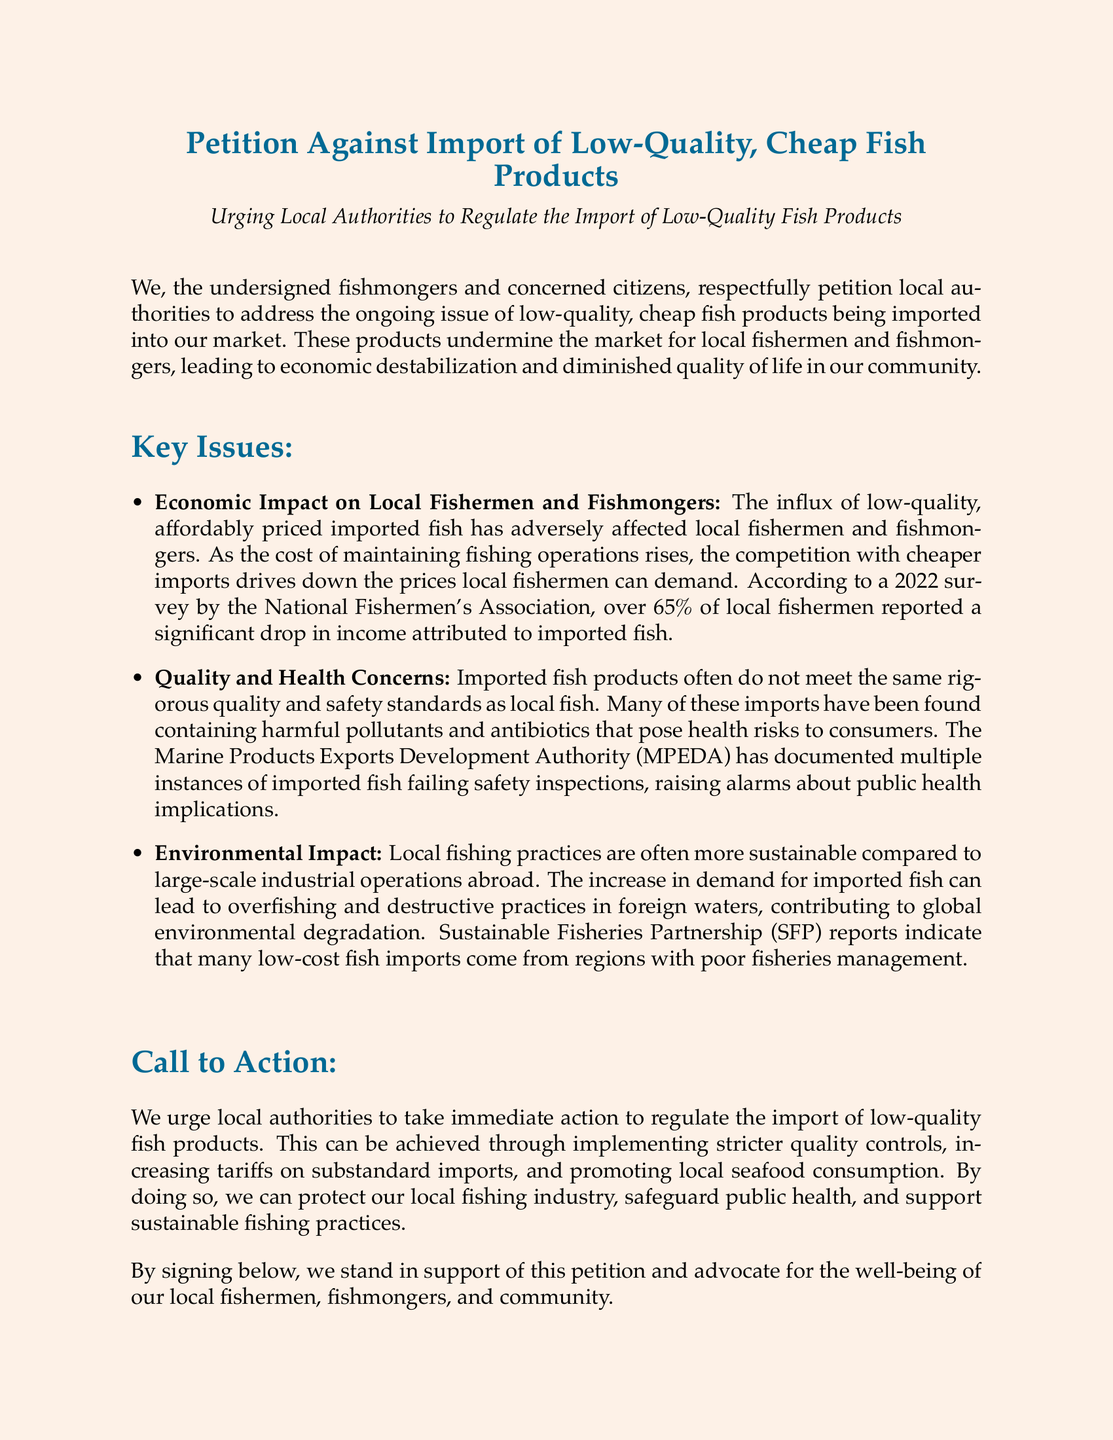what is the title of the petition? The title of the petition is presented at the beginning of the document, clearly stating its purpose.
Answer: Petition Against Import of Low-Quality, Cheap Fish Products what percentage of local fishermen reported a significant drop in income? The document includes a statistic from a 2022 survey regarding local fishermen's income, specifically the portion that experienced a drop.
Answer: 65% who conducted the survey mentioned in the petition? The document attributes the survey data to a specific organization that collected information on local fishermen's income.
Answer: National Fishermen's Association what are the suggested actions for local authorities? The document outlines specific recommendations aimed at addressing the issue of low-quality fish imports, detailing the proposed actions.
Answer: Implementing stricter quality controls, increasing tariffs on substandard imports, and promoting local seafood consumption what is one quality concern mentioned about imported fish? The petition includes information about the potential health risks associated with imported fish, highlighting specific contaminants that may be present.
Answer: Harmful pollutants and antibiotics what is the environmental concern mentioned in the petition? The document references specific negative impacts related to environmental practices in foreign fishing industries due to increased demand for imports.
Answer: Overfishing and destructive practices what authority has documented instances of imported fish failing safety inspections? The document cites an organization that has reported on safety inspections of imported fish, indicating their role in monitoring quality standards.
Answer: Marine Products Exports Development Authority (MPEDA) what is the primary audience of this petition? The document specifies who the petition is directed at, outlining the key stakeholders it seeks to address.
Answer: Local authorities 